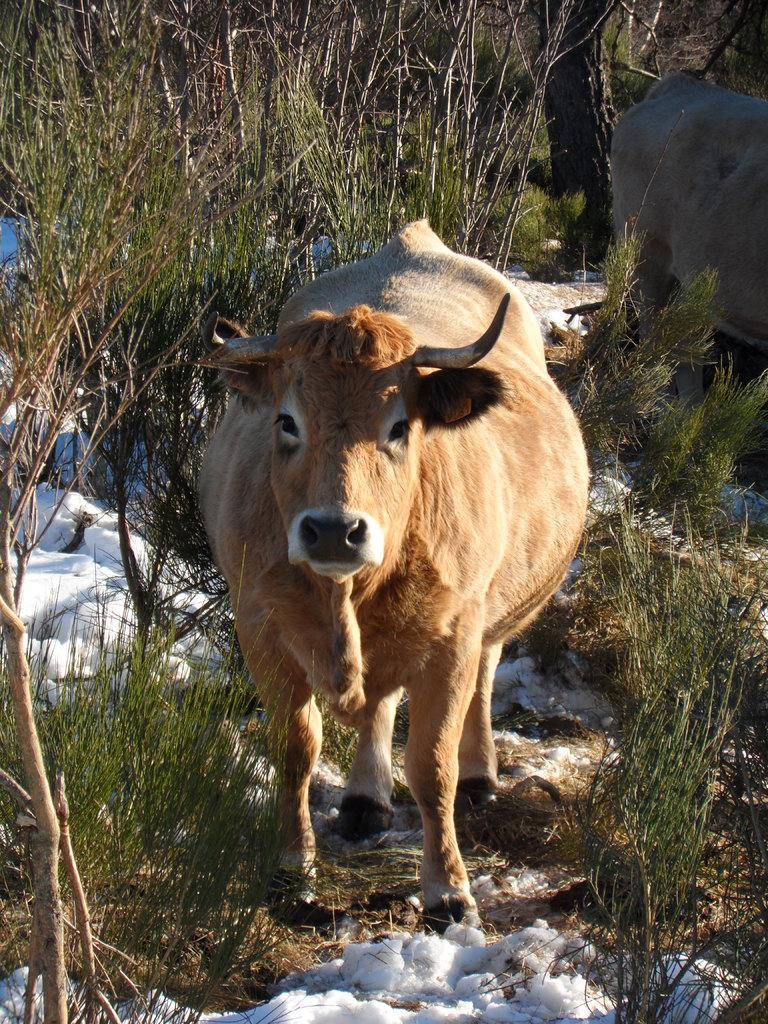What types of living organisms can be seen in the image? There are animals in the image. What natural elements are present in the image? There are trees and plants in the image. What is the ground covered with in the image? There is snow at the bottom of the image. What type of flesh can be seen hanging from the trees in the image? There is no flesh hanging from the trees in the image; it only contains animals, trees, plants, and snow. 